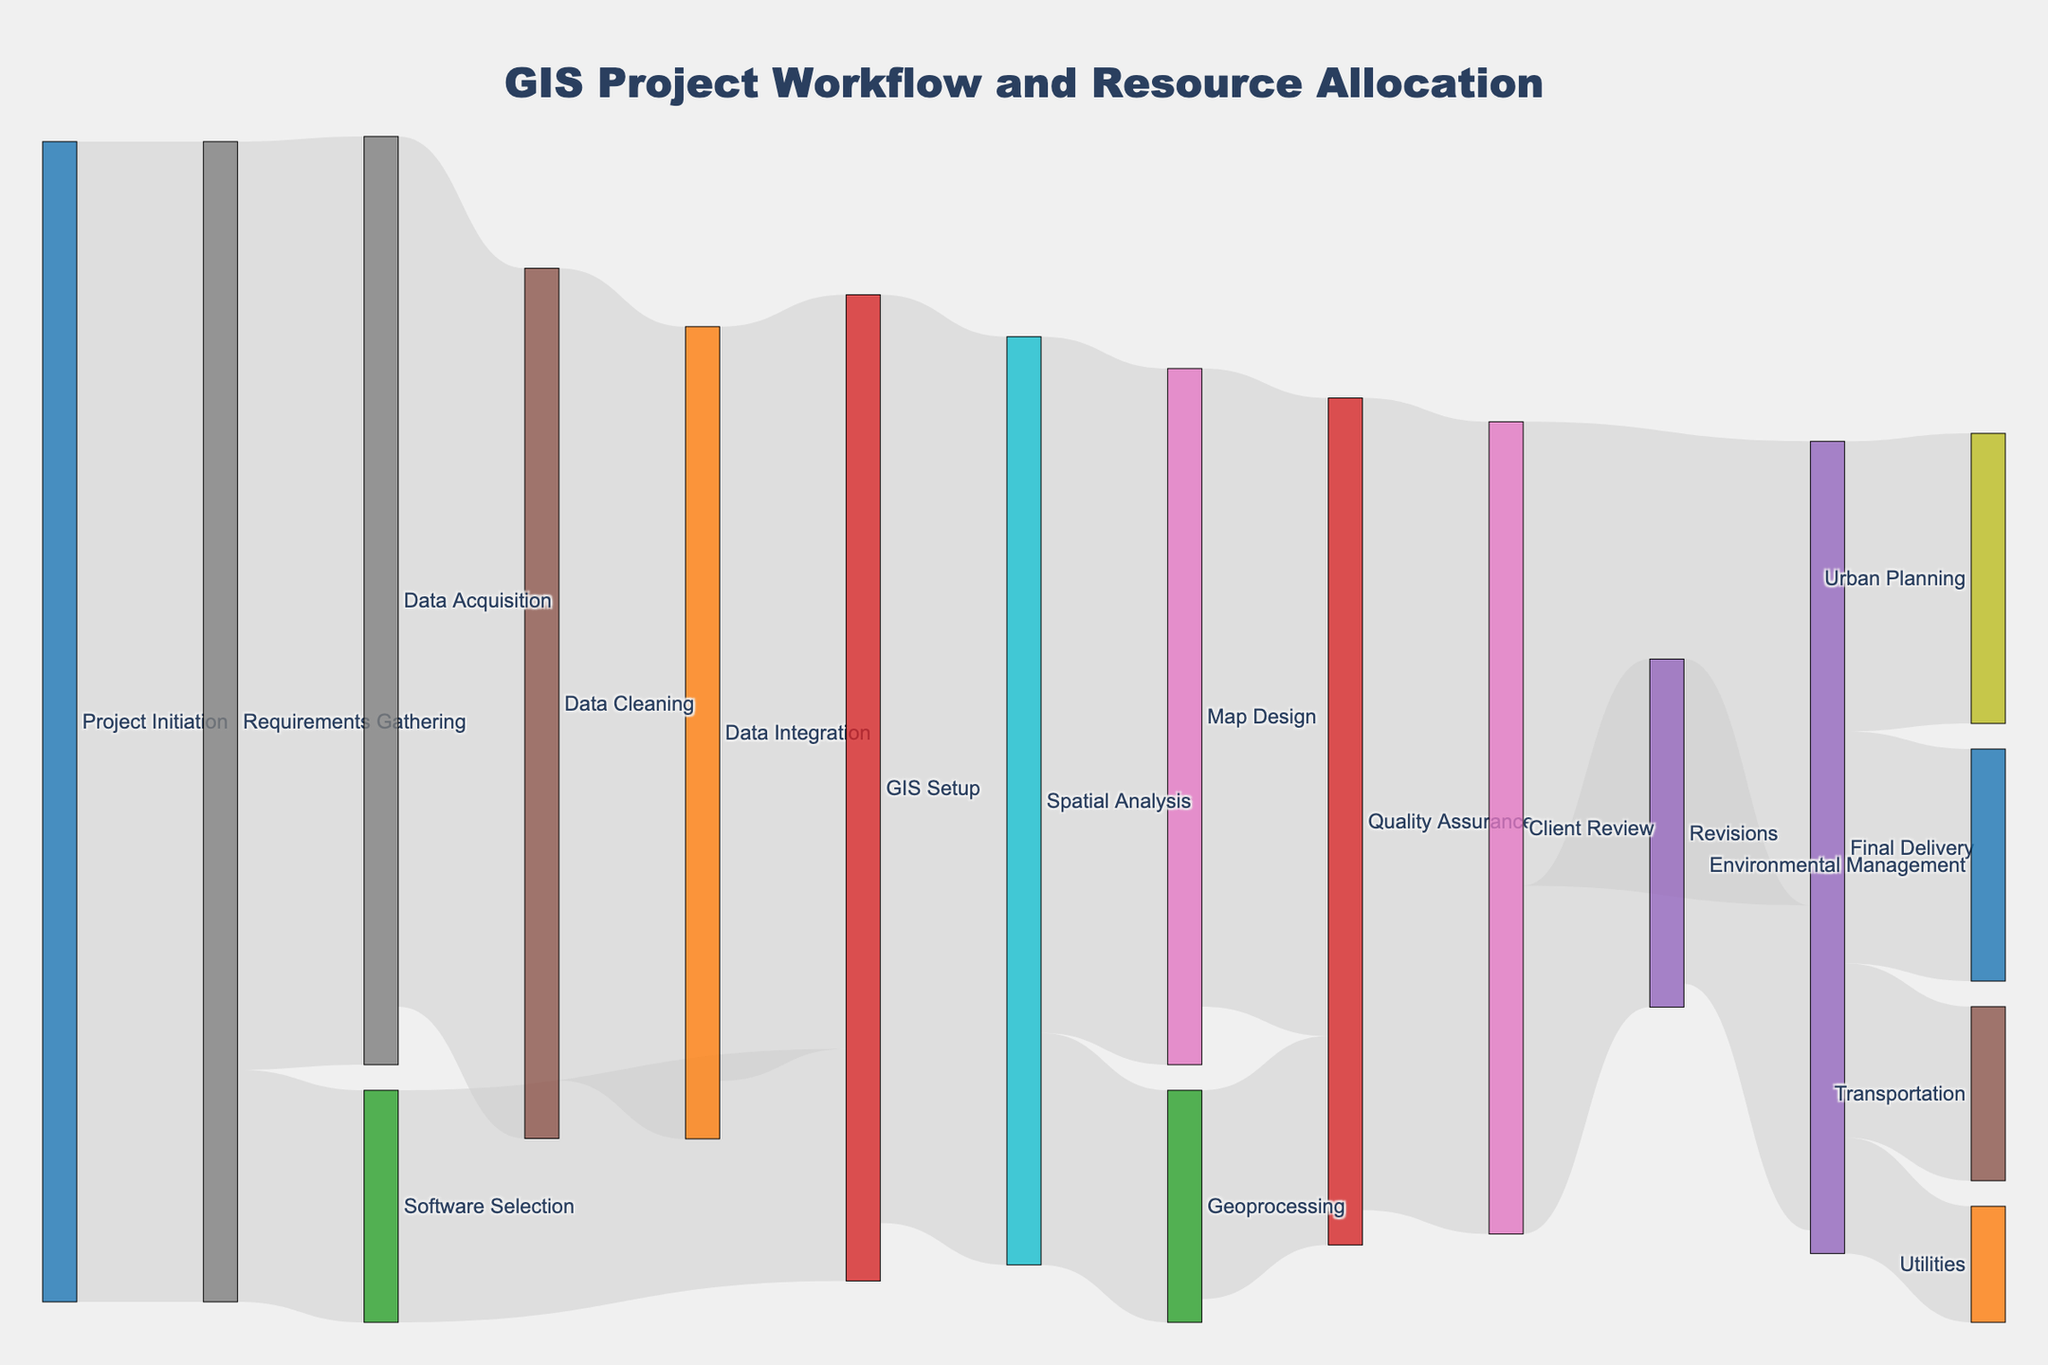what is the title of the figure? The title is located at the top of the figure and is easily noticeable with a larger font size and central alignment. The title reads "GIS Project Workflow and Resource Allocation".
Answer: GIS Project Workflow and Resource Allocation How many stages are there between Project Initiation and Final Delivery? Trace the paths from the "Project Initiation" node to the "Final Delivery" node. The paths go through multiple stages but accounting for unique stages by name, includes: Project Initiation, Requirements Gathering, Data Acquisition, Software Selection, Data Cleaning, Data Integration, GIS Setup, Spatial Analysis, Map Design, Geoprocessing, Quality Assurance, Client Review, Revisions, and Final Delivery. This makes 14 stages in total.
Answer: 14 Which stage has the highest number of subsequent pathways branching out? Examine each node to see how many links (pathways) exit from it. The "Final Delivery" node has the highest with four subsequent pathways branching out to Urban Planning, Environmental Management, Transportation, and Utilities.
Answer: Final Delivery What is the total value of resources allocated to Spatial Analysis? Sum the values of pathways entering and exiting "Spatial Analysis". Inputs total 80 from GIS Setup. Outputs total 60 to Map Design and 20 to Geoprocessing. Thus, the total is 80 (in) + 60 (out) + 20 (out) = 160.
Answer: 160 Which stage has the least resource allocation after Data Integration? The stages immediately following Data Integration are GIS Setup and a partial follow-through to GIS Setup from Data Cleaning, total 65. The next node with the least value is one directly after GIS Setup. Geoprocessing receives only 20 after Spatial Analysis, which is less than Map Design (60).
Answer: Geoprocessing What is the difference in resource allocation between Revisions and Final Delivery? The resources allocated to "Revisions" are 30, while to "Final Delivery" from Client Review it's 40 and from Revisions, 28. At "Final Delivery", totals are 40+28=68. The difference is thus 68 - 30 = 38.
Answer: 38 Which client industry receives the most resources at the end of workflow? Compare the values at the final stage for different client industries. Urban Planning receives 25, Environmental Management 20, Transportation 15, and Utilities 10. The highest value is for Urban Planning, which receives 25.
Answer: Urban Planning What's the combined resource allocation from Quality Assurance to Final Delivery? Calculate the sum of all values transitioning from Quality Assurance to Final Delivery excluding other transitions through Client Review or Revisions. From Quality Assurance to Final Delivery: 70 to Client Review, 30 to Revisions, to Final Delivery (40). Combining totals: 55 from Map Design + 18 from Geoprocessing = 73 directly to Quality Assurance and combined transition totals to Final Delivery sum is 70+30+40+28=168.
Answer: 70 How many pathways flow into Client Review? Count the number of direct links flowing into the "Client Review" node. There is only one pathway flowing into Client Review, originating from Quality Assurance.
Answer: 1 What's the resource difference between Data Acquisition and Data Cleaning phases? The pathway from Data Acquisition to Data Cleaning shows a value of 75, while Data Acquisition inputs from Requirements Gathering totals to 80. This makes 80-75=5 the transition difference resulting in cleaning phase's input more than its output.
Answer: 5 